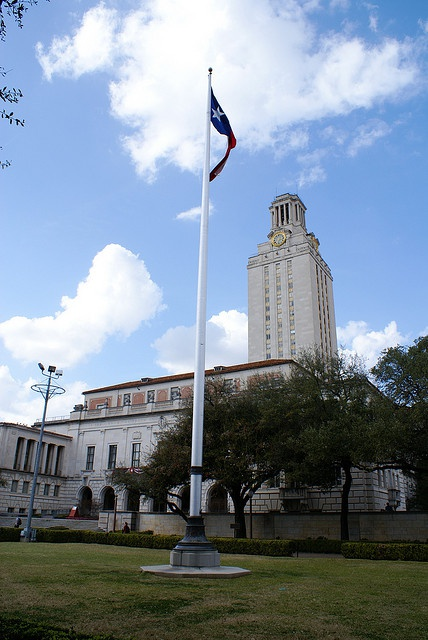Describe the objects in this image and their specific colors. I can see clock in black, darkgray, tan, and gray tones and people in black and gray tones in this image. 